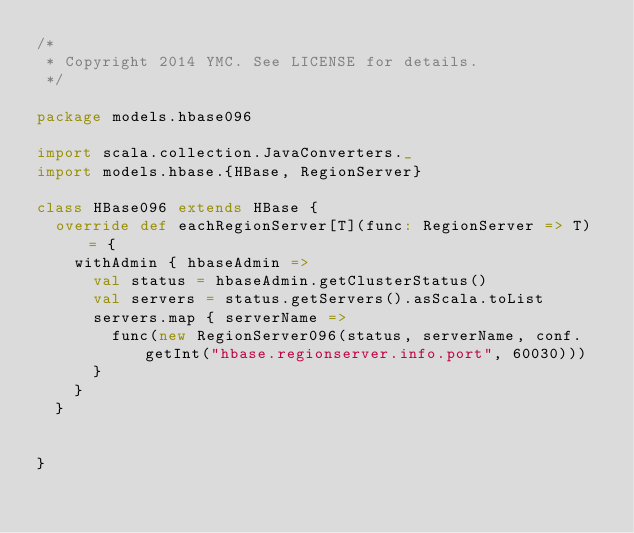<code> <loc_0><loc_0><loc_500><loc_500><_Scala_>/*
 * Copyright 2014 YMC. See LICENSE for details.
 */

package models.hbase096

import scala.collection.JavaConverters._
import models.hbase.{HBase, RegionServer}

class HBase096 extends HBase {
  override def eachRegionServer[T](func: RegionServer => T) = {
    withAdmin { hbaseAdmin =>
      val status = hbaseAdmin.getClusterStatus()
      val servers = status.getServers().asScala.toList
      servers.map { serverName =>
        func(new RegionServer096(status, serverName, conf.getInt("hbase.regionserver.info.port", 60030)))
      }
    }
  }


}
</code> 